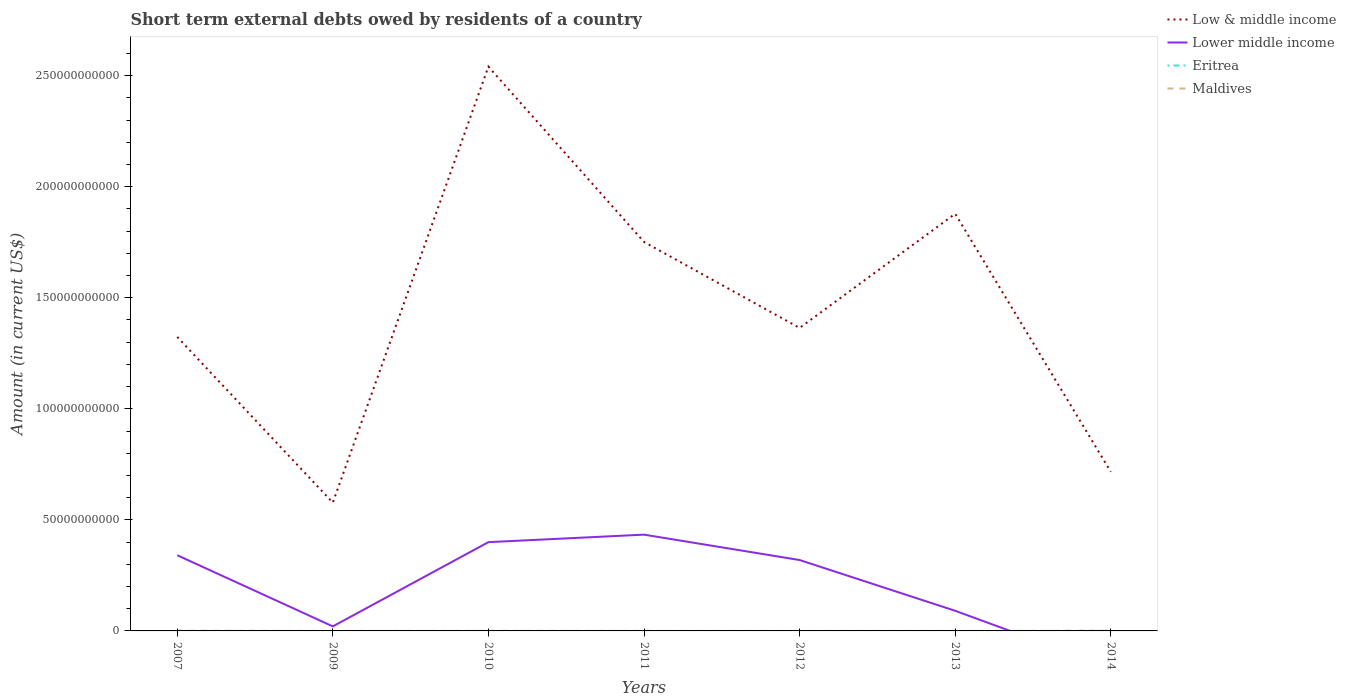How many different coloured lines are there?
Offer a terse response. 4. Is the number of lines equal to the number of legend labels?
Provide a short and direct response. No. Across all years, what is the maximum amount of short-term external debts owed by residents in Eritrea?
Offer a terse response. 0. What is the total amount of short-term external debts owed by residents in Low & middle income in the graph?
Your answer should be compact. -1.96e+11. What is the difference between the highest and the second highest amount of short-term external debts owed by residents in Low & middle income?
Ensure brevity in your answer.  1.96e+11. What is the difference between two consecutive major ticks on the Y-axis?
Offer a terse response. 5.00e+1. Are the values on the major ticks of Y-axis written in scientific E-notation?
Give a very brief answer. No. Does the graph contain any zero values?
Ensure brevity in your answer.  Yes. Does the graph contain grids?
Keep it short and to the point. No. Where does the legend appear in the graph?
Provide a succinct answer. Top right. How many legend labels are there?
Provide a short and direct response. 4. How are the legend labels stacked?
Make the answer very short. Vertical. What is the title of the graph?
Provide a succinct answer. Short term external debts owed by residents of a country. Does "Venezuela" appear as one of the legend labels in the graph?
Offer a terse response. No. What is the label or title of the Y-axis?
Offer a very short reply. Amount (in current US$). What is the Amount (in current US$) of Low & middle income in 2007?
Offer a terse response. 1.32e+11. What is the Amount (in current US$) in Lower middle income in 2007?
Keep it short and to the point. 3.41e+1. What is the Amount (in current US$) of Eritrea in 2007?
Ensure brevity in your answer.  0. What is the Amount (in current US$) in Maldives in 2007?
Ensure brevity in your answer.  8.91e+07. What is the Amount (in current US$) of Low & middle income in 2009?
Your answer should be very brief. 5.78e+1. What is the Amount (in current US$) in Lower middle income in 2009?
Offer a very short reply. 2.04e+09. What is the Amount (in current US$) in Eritrea in 2009?
Make the answer very short. 0. What is the Amount (in current US$) of Maldives in 2009?
Provide a short and direct response. 0. What is the Amount (in current US$) in Low & middle income in 2010?
Your answer should be very brief. 2.54e+11. What is the Amount (in current US$) in Lower middle income in 2010?
Provide a succinct answer. 4.00e+1. What is the Amount (in current US$) in Maldives in 2010?
Make the answer very short. 3.61e+07. What is the Amount (in current US$) of Low & middle income in 2011?
Provide a succinct answer. 1.75e+11. What is the Amount (in current US$) in Lower middle income in 2011?
Make the answer very short. 4.33e+1. What is the Amount (in current US$) of Maldives in 2011?
Ensure brevity in your answer.  7.15e+06. What is the Amount (in current US$) in Low & middle income in 2012?
Provide a short and direct response. 1.36e+11. What is the Amount (in current US$) in Lower middle income in 2012?
Offer a very short reply. 3.19e+1. What is the Amount (in current US$) in Maldives in 2012?
Your response must be concise. 0. What is the Amount (in current US$) in Low & middle income in 2013?
Give a very brief answer. 1.88e+11. What is the Amount (in current US$) in Lower middle income in 2013?
Keep it short and to the point. 9.06e+09. What is the Amount (in current US$) in Eritrea in 2013?
Offer a very short reply. 4.00e+06. What is the Amount (in current US$) in Low & middle income in 2014?
Offer a very short reply. 7.16e+1. What is the Amount (in current US$) in Lower middle income in 2014?
Ensure brevity in your answer.  0. What is the Amount (in current US$) in Eritrea in 2014?
Ensure brevity in your answer.  2.80e+07. What is the Amount (in current US$) of Maldives in 2014?
Your response must be concise. 9.82e+07. Across all years, what is the maximum Amount (in current US$) in Low & middle income?
Offer a terse response. 2.54e+11. Across all years, what is the maximum Amount (in current US$) of Lower middle income?
Your answer should be compact. 4.33e+1. Across all years, what is the maximum Amount (in current US$) of Eritrea?
Your response must be concise. 2.80e+07. Across all years, what is the maximum Amount (in current US$) of Maldives?
Keep it short and to the point. 9.82e+07. Across all years, what is the minimum Amount (in current US$) of Low & middle income?
Your response must be concise. 5.78e+1. Across all years, what is the minimum Amount (in current US$) of Lower middle income?
Offer a very short reply. 0. Across all years, what is the minimum Amount (in current US$) of Eritrea?
Ensure brevity in your answer.  0. Across all years, what is the minimum Amount (in current US$) in Maldives?
Provide a short and direct response. 0. What is the total Amount (in current US$) in Low & middle income in the graph?
Your response must be concise. 1.02e+12. What is the total Amount (in current US$) in Lower middle income in the graph?
Make the answer very short. 1.60e+11. What is the total Amount (in current US$) in Eritrea in the graph?
Make the answer very short. 3.50e+07. What is the total Amount (in current US$) in Maldives in the graph?
Give a very brief answer. 2.31e+08. What is the difference between the Amount (in current US$) of Low & middle income in 2007 and that in 2009?
Ensure brevity in your answer.  7.46e+1. What is the difference between the Amount (in current US$) in Lower middle income in 2007 and that in 2009?
Your answer should be compact. 3.20e+1. What is the difference between the Amount (in current US$) of Low & middle income in 2007 and that in 2010?
Ensure brevity in your answer.  -1.22e+11. What is the difference between the Amount (in current US$) in Lower middle income in 2007 and that in 2010?
Make the answer very short. -5.88e+09. What is the difference between the Amount (in current US$) in Maldives in 2007 and that in 2010?
Your answer should be compact. 5.30e+07. What is the difference between the Amount (in current US$) in Low & middle income in 2007 and that in 2011?
Keep it short and to the point. -4.28e+1. What is the difference between the Amount (in current US$) in Lower middle income in 2007 and that in 2011?
Ensure brevity in your answer.  -9.26e+09. What is the difference between the Amount (in current US$) in Maldives in 2007 and that in 2011?
Give a very brief answer. 8.19e+07. What is the difference between the Amount (in current US$) of Low & middle income in 2007 and that in 2012?
Provide a succinct answer. -4.05e+09. What is the difference between the Amount (in current US$) of Lower middle income in 2007 and that in 2012?
Offer a very short reply. 2.17e+09. What is the difference between the Amount (in current US$) of Low & middle income in 2007 and that in 2013?
Your answer should be very brief. -5.55e+1. What is the difference between the Amount (in current US$) in Lower middle income in 2007 and that in 2013?
Your response must be concise. 2.50e+1. What is the difference between the Amount (in current US$) of Low & middle income in 2007 and that in 2014?
Ensure brevity in your answer.  6.07e+1. What is the difference between the Amount (in current US$) in Maldives in 2007 and that in 2014?
Your answer should be very brief. -9.10e+06. What is the difference between the Amount (in current US$) of Low & middle income in 2009 and that in 2010?
Provide a short and direct response. -1.96e+11. What is the difference between the Amount (in current US$) of Lower middle income in 2009 and that in 2010?
Ensure brevity in your answer.  -3.79e+1. What is the difference between the Amount (in current US$) in Low & middle income in 2009 and that in 2011?
Offer a very short reply. -1.17e+11. What is the difference between the Amount (in current US$) in Lower middle income in 2009 and that in 2011?
Make the answer very short. -4.13e+1. What is the difference between the Amount (in current US$) of Low & middle income in 2009 and that in 2012?
Provide a succinct answer. -7.86e+1. What is the difference between the Amount (in current US$) of Lower middle income in 2009 and that in 2012?
Keep it short and to the point. -2.99e+1. What is the difference between the Amount (in current US$) of Low & middle income in 2009 and that in 2013?
Offer a terse response. -1.30e+11. What is the difference between the Amount (in current US$) of Lower middle income in 2009 and that in 2013?
Your answer should be very brief. -7.02e+09. What is the difference between the Amount (in current US$) in Low & middle income in 2009 and that in 2014?
Make the answer very short. -1.39e+1. What is the difference between the Amount (in current US$) in Low & middle income in 2010 and that in 2011?
Provide a succinct answer. 7.89e+1. What is the difference between the Amount (in current US$) of Lower middle income in 2010 and that in 2011?
Make the answer very short. -3.38e+09. What is the difference between the Amount (in current US$) in Eritrea in 2010 and that in 2011?
Your response must be concise. 1.00e+06. What is the difference between the Amount (in current US$) of Maldives in 2010 and that in 2011?
Provide a short and direct response. 2.90e+07. What is the difference between the Amount (in current US$) of Low & middle income in 2010 and that in 2012?
Your answer should be compact. 1.18e+11. What is the difference between the Amount (in current US$) of Lower middle income in 2010 and that in 2012?
Keep it short and to the point. 8.05e+09. What is the difference between the Amount (in current US$) in Low & middle income in 2010 and that in 2013?
Your answer should be very brief. 6.62e+1. What is the difference between the Amount (in current US$) of Lower middle income in 2010 and that in 2013?
Provide a short and direct response. 3.09e+1. What is the difference between the Amount (in current US$) of Low & middle income in 2010 and that in 2014?
Offer a very short reply. 1.82e+11. What is the difference between the Amount (in current US$) in Eritrea in 2010 and that in 2014?
Offer a very short reply. -2.60e+07. What is the difference between the Amount (in current US$) of Maldives in 2010 and that in 2014?
Ensure brevity in your answer.  -6.21e+07. What is the difference between the Amount (in current US$) of Low & middle income in 2011 and that in 2012?
Keep it short and to the point. 3.87e+1. What is the difference between the Amount (in current US$) of Lower middle income in 2011 and that in 2012?
Keep it short and to the point. 1.14e+1. What is the difference between the Amount (in current US$) of Low & middle income in 2011 and that in 2013?
Your answer should be compact. -1.27e+1. What is the difference between the Amount (in current US$) in Lower middle income in 2011 and that in 2013?
Offer a terse response. 3.43e+1. What is the difference between the Amount (in current US$) of Eritrea in 2011 and that in 2013?
Offer a very short reply. -3.00e+06. What is the difference between the Amount (in current US$) in Low & middle income in 2011 and that in 2014?
Your answer should be very brief. 1.03e+11. What is the difference between the Amount (in current US$) in Eritrea in 2011 and that in 2014?
Give a very brief answer. -2.70e+07. What is the difference between the Amount (in current US$) of Maldives in 2011 and that in 2014?
Provide a succinct answer. -9.10e+07. What is the difference between the Amount (in current US$) of Low & middle income in 2012 and that in 2013?
Your response must be concise. -5.14e+1. What is the difference between the Amount (in current US$) of Lower middle income in 2012 and that in 2013?
Make the answer very short. 2.29e+1. What is the difference between the Amount (in current US$) of Low & middle income in 2012 and that in 2014?
Make the answer very short. 6.48e+1. What is the difference between the Amount (in current US$) in Low & middle income in 2013 and that in 2014?
Offer a very short reply. 1.16e+11. What is the difference between the Amount (in current US$) in Eritrea in 2013 and that in 2014?
Your response must be concise. -2.40e+07. What is the difference between the Amount (in current US$) in Low & middle income in 2007 and the Amount (in current US$) in Lower middle income in 2009?
Your answer should be very brief. 1.30e+11. What is the difference between the Amount (in current US$) in Low & middle income in 2007 and the Amount (in current US$) in Lower middle income in 2010?
Offer a terse response. 9.24e+1. What is the difference between the Amount (in current US$) of Low & middle income in 2007 and the Amount (in current US$) of Eritrea in 2010?
Your answer should be very brief. 1.32e+11. What is the difference between the Amount (in current US$) in Low & middle income in 2007 and the Amount (in current US$) in Maldives in 2010?
Provide a succinct answer. 1.32e+11. What is the difference between the Amount (in current US$) in Lower middle income in 2007 and the Amount (in current US$) in Eritrea in 2010?
Offer a very short reply. 3.41e+1. What is the difference between the Amount (in current US$) in Lower middle income in 2007 and the Amount (in current US$) in Maldives in 2010?
Ensure brevity in your answer.  3.40e+1. What is the difference between the Amount (in current US$) of Low & middle income in 2007 and the Amount (in current US$) of Lower middle income in 2011?
Provide a short and direct response. 8.90e+1. What is the difference between the Amount (in current US$) of Low & middle income in 2007 and the Amount (in current US$) of Eritrea in 2011?
Give a very brief answer. 1.32e+11. What is the difference between the Amount (in current US$) in Low & middle income in 2007 and the Amount (in current US$) in Maldives in 2011?
Provide a succinct answer. 1.32e+11. What is the difference between the Amount (in current US$) in Lower middle income in 2007 and the Amount (in current US$) in Eritrea in 2011?
Provide a succinct answer. 3.41e+1. What is the difference between the Amount (in current US$) in Lower middle income in 2007 and the Amount (in current US$) in Maldives in 2011?
Ensure brevity in your answer.  3.41e+1. What is the difference between the Amount (in current US$) in Low & middle income in 2007 and the Amount (in current US$) in Lower middle income in 2012?
Offer a very short reply. 1.00e+11. What is the difference between the Amount (in current US$) of Low & middle income in 2007 and the Amount (in current US$) of Lower middle income in 2013?
Your answer should be compact. 1.23e+11. What is the difference between the Amount (in current US$) in Low & middle income in 2007 and the Amount (in current US$) in Eritrea in 2013?
Keep it short and to the point. 1.32e+11. What is the difference between the Amount (in current US$) in Lower middle income in 2007 and the Amount (in current US$) in Eritrea in 2013?
Give a very brief answer. 3.41e+1. What is the difference between the Amount (in current US$) in Low & middle income in 2007 and the Amount (in current US$) in Eritrea in 2014?
Offer a very short reply. 1.32e+11. What is the difference between the Amount (in current US$) of Low & middle income in 2007 and the Amount (in current US$) of Maldives in 2014?
Ensure brevity in your answer.  1.32e+11. What is the difference between the Amount (in current US$) in Lower middle income in 2007 and the Amount (in current US$) in Eritrea in 2014?
Offer a terse response. 3.41e+1. What is the difference between the Amount (in current US$) in Lower middle income in 2007 and the Amount (in current US$) in Maldives in 2014?
Keep it short and to the point. 3.40e+1. What is the difference between the Amount (in current US$) in Low & middle income in 2009 and the Amount (in current US$) in Lower middle income in 2010?
Provide a succinct answer. 1.78e+1. What is the difference between the Amount (in current US$) in Low & middle income in 2009 and the Amount (in current US$) in Eritrea in 2010?
Ensure brevity in your answer.  5.78e+1. What is the difference between the Amount (in current US$) of Low & middle income in 2009 and the Amount (in current US$) of Maldives in 2010?
Your answer should be very brief. 5.77e+1. What is the difference between the Amount (in current US$) of Lower middle income in 2009 and the Amount (in current US$) of Eritrea in 2010?
Give a very brief answer. 2.04e+09. What is the difference between the Amount (in current US$) in Lower middle income in 2009 and the Amount (in current US$) in Maldives in 2010?
Your answer should be very brief. 2.01e+09. What is the difference between the Amount (in current US$) in Low & middle income in 2009 and the Amount (in current US$) in Lower middle income in 2011?
Provide a short and direct response. 1.44e+1. What is the difference between the Amount (in current US$) of Low & middle income in 2009 and the Amount (in current US$) of Eritrea in 2011?
Your answer should be very brief. 5.78e+1. What is the difference between the Amount (in current US$) in Low & middle income in 2009 and the Amount (in current US$) in Maldives in 2011?
Your answer should be very brief. 5.78e+1. What is the difference between the Amount (in current US$) of Lower middle income in 2009 and the Amount (in current US$) of Eritrea in 2011?
Ensure brevity in your answer.  2.04e+09. What is the difference between the Amount (in current US$) in Lower middle income in 2009 and the Amount (in current US$) in Maldives in 2011?
Offer a terse response. 2.03e+09. What is the difference between the Amount (in current US$) of Low & middle income in 2009 and the Amount (in current US$) of Lower middle income in 2012?
Keep it short and to the point. 2.58e+1. What is the difference between the Amount (in current US$) in Low & middle income in 2009 and the Amount (in current US$) in Lower middle income in 2013?
Keep it short and to the point. 4.87e+1. What is the difference between the Amount (in current US$) in Low & middle income in 2009 and the Amount (in current US$) in Eritrea in 2013?
Offer a terse response. 5.78e+1. What is the difference between the Amount (in current US$) of Lower middle income in 2009 and the Amount (in current US$) of Eritrea in 2013?
Provide a short and direct response. 2.04e+09. What is the difference between the Amount (in current US$) of Low & middle income in 2009 and the Amount (in current US$) of Eritrea in 2014?
Offer a terse response. 5.77e+1. What is the difference between the Amount (in current US$) of Low & middle income in 2009 and the Amount (in current US$) of Maldives in 2014?
Provide a succinct answer. 5.77e+1. What is the difference between the Amount (in current US$) in Lower middle income in 2009 and the Amount (in current US$) in Eritrea in 2014?
Make the answer very short. 2.01e+09. What is the difference between the Amount (in current US$) in Lower middle income in 2009 and the Amount (in current US$) in Maldives in 2014?
Give a very brief answer. 1.94e+09. What is the difference between the Amount (in current US$) in Low & middle income in 2010 and the Amount (in current US$) in Lower middle income in 2011?
Give a very brief answer. 2.11e+11. What is the difference between the Amount (in current US$) of Low & middle income in 2010 and the Amount (in current US$) of Eritrea in 2011?
Your answer should be very brief. 2.54e+11. What is the difference between the Amount (in current US$) in Low & middle income in 2010 and the Amount (in current US$) in Maldives in 2011?
Your answer should be compact. 2.54e+11. What is the difference between the Amount (in current US$) of Lower middle income in 2010 and the Amount (in current US$) of Eritrea in 2011?
Your response must be concise. 4.00e+1. What is the difference between the Amount (in current US$) in Lower middle income in 2010 and the Amount (in current US$) in Maldives in 2011?
Your answer should be compact. 4.00e+1. What is the difference between the Amount (in current US$) in Eritrea in 2010 and the Amount (in current US$) in Maldives in 2011?
Offer a very short reply. -5.15e+06. What is the difference between the Amount (in current US$) in Low & middle income in 2010 and the Amount (in current US$) in Lower middle income in 2012?
Make the answer very short. 2.22e+11. What is the difference between the Amount (in current US$) in Low & middle income in 2010 and the Amount (in current US$) in Lower middle income in 2013?
Provide a succinct answer. 2.45e+11. What is the difference between the Amount (in current US$) in Low & middle income in 2010 and the Amount (in current US$) in Eritrea in 2013?
Provide a short and direct response. 2.54e+11. What is the difference between the Amount (in current US$) in Lower middle income in 2010 and the Amount (in current US$) in Eritrea in 2013?
Your answer should be very brief. 4.00e+1. What is the difference between the Amount (in current US$) in Low & middle income in 2010 and the Amount (in current US$) in Eritrea in 2014?
Provide a short and direct response. 2.54e+11. What is the difference between the Amount (in current US$) in Low & middle income in 2010 and the Amount (in current US$) in Maldives in 2014?
Provide a short and direct response. 2.54e+11. What is the difference between the Amount (in current US$) in Lower middle income in 2010 and the Amount (in current US$) in Eritrea in 2014?
Make the answer very short. 3.99e+1. What is the difference between the Amount (in current US$) in Lower middle income in 2010 and the Amount (in current US$) in Maldives in 2014?
Your answer should be compact. 3.99e+1. What is the difference between the Amount (in current US$) in Eritrea in 2010 and the Amount (in current US$) in Maldives in 2014?
Your answer should be compact. -9.62e+07. What is the difference between the Amount (in current US$) of Low & middle income in 2011 and the Amount (in current US$) of Lower middle income in 2012?
Ensure brevity in your answer.  1.43e+11. What is the difference between the Amount (in current US$) of Low & middle income in 2011 and the Amount (in current US$) of Lower middle income in 2013?
Offer a very short reply. 1.66e+11. What is the difference between the Amount (in current US$) of Low & middle income in 2011 and the Amount (in current US$) of Eritrea in 2013?
Offer a terse response. 1.75e+11. What is the difference between the Amount (in current US$) of Lower middle income in 2011 and the Amount (in current US$) of Eritrea in 2013?
Offer a terse response. 4.33e+1. What is the difference between the Amount (in current US$) of Low & middle income in 2011 and the Amount (in current US$) of Eritrea in 2014?
Your answer should be very brief. 1.75e+11. What is the difference between the Amount (in current US$) in Low & middle income in 2011 and the Amount (in current US$) in Maldives in 2014?
Provide a succinct answer. 1.75e+11. What is the difference between the Amount (in current US$) in Lower middle income in 2011 and the Amount (in current US$) in Eritrea in 2014?
Offer a very short reply. 4.33e+1. What is the difference between the Amount (in current US$) of Lower middle income in 2011 and the Amount (in current US$) of Maldives in 2014?
Offer a terse response. 4.32e+1. What is the difference between the Amount (in current US$) in Eritrea in 2011 and the Amount (in current US$) in Maldives in 2014?
Your answer should be compact. -9.72e+07. What is the difference between the Amount (in current US$) in Low & middle income in 2012 and the Amount (in current US$) in Lower middle income in 2013?
Provide a short and direct response. 1.27e+11. What is the difference between the Amount (in current US$) of Low & middle income in 2012 and the Amount (in current US$) of Eritrea in 2013?
Ensure brevity in your answer.  1.36e+11. What is the difference between the Amount (in current US$) in Lower middle income in 2012 and the Amount (in current US$) in Eritrea in 2013?
Offer a very short reply. 3.19e+1. What is the difference between the Amount (in current US$) in Low & middle income in 2012 and the Amount (in current US$) in Eritrea in 2014?
Provide a succinct answer. 1.36e+11. What is the difference between the Amount (in current US$) in Low & middle income in 2012 and the Amount (in current US$) in Maldives in 2014?
Offer a terse response. 1.36e+11. What is the difference between the Amount (in current US$) in Lower middle income in 2012 and the Amount (in current US$) in Eritrea in 2014?
Provide a short and direct response. 3.19e+1. What is the difference between the Amount (in current US$) in Lower middle income in 2012 and the Amount (in current US$) in Maldives in 2014?
Give a very brief answer. 3.18e+1. What is the difference between the Amount (in current US$) of Low & middle income in 2013 and the Amount (in current US$) of Eritrea in 2014?
Your answer should be very brief. 1.88e+11. What is the difference between the Amount (in current US$) of Low & middle income in 2013 and the Amount (in current US$) of Maldives in 2014?
Give a very brief answer. 1.88e+11. What is the difference between the Amount (in current US$) of Lower middle income in 2013 and the Amount (in current US$) of Eritrea in 2014?
Keep it short and to the point. 9.03e+09. What is the difference between the Amount (in current US$) in Lower middle income in 2013 and the Amount (in current US$) in Maldives in 2014?
Keep it short and to the point. 8.96e+09. What is the difference between the Amount (in current US$) in Eritrea in 2013 and the Amount (in current US$) in Maldives in 2014?
Provide a succinct answer. -9.42e+07. What is the average Amount (in current US$) in Low & middle income per year?
Your answer should be compact. 1.45e+11. What is the average Amount (in current US$) in Lower middle income per year?
Your answer should be very brief. 2.29e+1. What is the average Amount (in current US$) in Eritrea per year?
Your answer should be very brief. 5.00e+06. What is the average Amount (in current US$) of Maldives per year?
Offer a terse response. 3.29e+07. In the year 2007, what is the difference between the Amount (in current US$) in Low & middle income and Amount (in current US$) in Lower middle income?
Ensure brevity in your answer.  9.83e+1. In the year 2007, what is the difference between the Amount (in current US$) in Low & middle income and Amount (in current US$) in Maldives?
Your answer should be very brief. 1.32e+11. In the year 2007, what is the difference between the Amount (in current US$) in Lower middle income and Amount (in current US$) in Maldives?
Your answer should be very brief. 3.40e+1. In the year 2009, what is the difference between the Amount (in current US$) in Low & middle income and Amount (in current US$) in Lower middle income?
Give a very brief answer. 5.57e+1. In the year 2010, what is the difference between the Amount (in current US$) in Low & middle income and Amount (in current US$) in Lower middle income?
Your answer should be very brief. 2.14e+11. In the year 2010, what is the difference between the Amount (in current US$) in Low & middle income and Amount (in current US$) in Eritrea?
Your answer should be very brief. 2.54e+11. In the year 2010, what is the difference between the Amount (in current US$) in Low & middle income and Amount (in current US$) in Maldives?
Offer a terse response. 2.54e+11. In the year 2010, what is the difference between the Amount (in current US$) of Lower middle income and Amount (in current US$) of Eritrea?
Offer a terse response. 4.00e+1. In the year 2010, what is the difference between the Amount (in current US$) of Lower middle income and Amount (in current US$) of Maldives?
Your response must be concise. 3.99e+1. In the year 2010, what is the difference between the Amount (in current US$) of Eritrea and Amount (in current US$) of Maldives?
Provide a short and direct response. -3.41e+07. In the year 2011, what is the difference between the Amount (in current US$) in Low & middle income and Amount (in current US$) in Lower middle income?
Your answer should be compact. 1.32e+11. In the year 2011, what is the difference between the Amount (in current US$) of Low & middle income and Amount (in current US$) of Eritrea?
Provide a succinct answer. 1.75e+11. In the year 2011, what is the difference between the Amount (in current US$) in Low & middle income and Amount (in current US$) in Maldives?
Give a very brief answer. 1.75e+11. In the year 2011, what is the difference between the Amount (in current US$) in Lower middle income and Amount (in current US$) in Eritrea?
Give a very brief answer. 4.33e+1. In the year 2011, what is the difference between the Amount (in current US$) in Lower middle income and Amount (in current US$) in Maldives?
Keep it short and to the point. 4.33e+1. In the year 2011, what is the difference between the Amount (in current US$) in Eritrea and Amount (in current US$) in Maldives?
Your answer should be very brief. -6.15e+06. In the year 2012, what is the difference between the Amount (in current US$) of Low & middle income and Amount (in current US$) of Lower middle income?
Your answer should be compact. 1.04e+11. In the year 2013, what is the difference between the Amount (in current US$) of Low & middle income and Amount (in current US$) of Lower middle income?
Give a very brief answer. 1.79e+11. In the year 2013, what is the difference between the Amount (in current US$) of Low & middle income and Amount (in current US$) of Eritrea?
Offer a terse response. 1.88e+11. In the year 2013, what is the difference between the Amount (in current US$) in Lower middle income and Amount (in current US$) in Eritrea?
Offer a terse response. 9.05e+09. In the year 2014, what is the difference between the Amount (in current US$) in Low & middle income and Amount (in current US$) in Eritrea?
Your answer should be very brief. 7.16e+1. In the year 2014, what is the difference between the Amount (in current US$) of Low & middle income and Amount (in current US$) of Maldives?
Your response must be concise. 7.15e+1. In the year 2014, what is the difference between the Amount (in current US$) in Eritrea and Amount (in current US$) in Maldives?
Keep it short and to the point. -7.02e+07. What is the ratio of the Amount (in current US$) of Low & middle income in 2007 to that in 2009?
Make the answer very short. 2.29. What is the ratio of the Amount (in current US$) of Lower middle income in 2007 to that in 2009?
Offer a very short reply. 16.7. What is the ratio of the Amount (in current US$) in Low & middle income in 2007 to that in 2010?
Offer a very short reply. 0.52. What is the ratio of the Amount (in current US$) of Lower middle income in 2007 to that in 2010?
Keep it short and to the point. 0.85. What is the ratio of the Amount (in current US$) in Maldives in 2007 to that in 2010?
Make the answer very short. 2.47. What is the ratio of the Amount (in current US$) of Low & middle income in 2007 to that in 2011?
Make the answer very short. 0.76. What is the ratio of the Amount (in current US$) of Lower middle income in 2007 to that in 2011?
Give a very brief answer. 0.79. What is the ratio of the Amount (in current US$) of Maldives in 2007 to that in 2011?
Provide a short and direct response. 12.46. What is the ratio of the Amount (in current US$) in Low & middle income in 2007 to that in 2012?
Provide a short and direct response. 0.97. What is the ratio of the Amount (in current US$) in Lower middle income in 2007 to that in 2012?
Offer a very short reply. 1.07. What is the ratio of the Amount (in current US$) in Low & middle income in 2007 to that in 2013?
Offer a terse response. 0.7. What is the ratio of the Amount (in current US$) of Lower middle income in 2007 to that in 2013?
Give a very brief answer. 3.76. What is the ratio of the Amount (in current US$) of Low & middle income in 2007 to that in 2014?
Give a very brief answer. 1.85. What is the ratio of the Amount (in current US$) of Maldives in 2007 to that in 2014?
Provide a succinct answer. 0.91. What is the ratio of the Amount (in current US$) of Low & middle income in 2009 to that in 2010?
Make the answer very short. 0.23. What is the ratio of the Amount (in current US$) in Lower middle income in 2009 to that in 2010?
Offer a terse response. 0.05. What is the ratio of the Amount (in current US$) of Low & middle income in 2009 to that in 2011?
Offer a very short reply. 0.33. What is the ratio of the Amount (in current US$) of Lower middle income in 2009 to that in 2011?
Your response must be concise. 0.05. What is the ratio of the Amount (in current US$) of Low & middle income in 2009 to that in 2012?
Offer a very short reply. 0.42. What is the ratio of the Amount (in current US$) of Lower middle income in 2009 to that in 2012?
Provide a short and direct response. 0.06. What is the ratio of the Amount (in current US$) in Low & middle income in 2009 to that in 2013?
Keep it short and to the point. 0.31. What is the ratio of the Amount (in current US$) of Lower middle income in 2009 to that in 2013?
Offer a terse response. 0.23. What is the ratio of the Amount (in current US$) of Low & middle income in 2009 to that in 2014?
Ensure brevity in your answer.  0.81. What is the ratio of the Amount (in current US$) in Low & middle income in 2010 to that in 2011?
Provide a short and direct response. 1.45. What is the ratio of the Amount (in current US$) in Lower middle income in 2010 to that in 2011?
Give a very brief answer. 0.92. What is the ratio of the Amount (in current US$) of Eritrea in 2010 to that in 2011?
Provide a short and direct response. 2. What is the ratio of the Amount (in current US$) in Maldives in 2010 to that in 2011?
Make the answer very short. 5.05. What is the ratio of the Amount (in current US$) of Low & middle income in 2010 to that in 2012?
Offer a very short reply. 1.86. What is the ratio of the Amount (in current US$) of Lower middle income in 2010 to that in 2012?
Offer a very short reply. 1.25. What is the ratio of the Amount (in current US$) of Low & middle income in 2010 to that in 2013?
Your response must be concise. 1.35. What is the ratio of the Amount (in current US$) in Lower middle income in 2010 to that in 2013?
Give a very brief answer. 4.41. What is the ratio of the Amount (in current US$) in Low & middle income in 2010 to that in 2014?
Offer a very short reply. 3.55. What is the ratio of the Amount (in current US$) of Eritrea in 2010 to that in 2014?
Offer a terse response. 0.07. What is the ratio of the Amount (in current US$) in Maldives in 2010 to that in 2014?
Offer a terse response. 0.37. What is the ratio of the Amount (in current US$) of Low & middle income in 2011 to that in 2012?
Make the answer very short. 1.28. What is the ratio of the Amount (in current US$) in Lower middle income in 2011 to that in 2012?
Provide a succinct answer. 1.36. What is the ratio of the Amount (in current US$) of Low & middle income in 2011 to that in 2013?
Keep it short and to the point. 0.93. What is the ratio of the Amount (in current US$) in Lower middle income in 2011 to that in 2013?
Your answer should be very brief. 4.79. What is the ratio of the Amount (in current US$) in Low & middle income in 2011 to that in 2014?
Ensure brevity in your answer.  2.44. What is the ratio of the Amount (in current US$) in Eritrea in 2011 to that in 2014?
Ensure brevity in your answer.  0.04. What is the ratio of the Amount (in current US$) of Maldives in 2011 to that in 2014?
Your answer should be very brief. 0.07. What is the ratio of the Amount (in current US$) of Low & middle income in 2012 to that in 2013?
Offer a very short reply. 0.73. What is the ratio of the Amount (in current US$) of Lower middle income in 2012 to that in 2013?
Offer a very short reply. 3.52. What is the ratio of the Amount (in current US$) of Low & middle income in 2012 to that in 2014?
Your response must be concise. 1.9. What is the ratio of the Amount (in current US$) in Low & middle income in 2013 to that in 2014?
Offer a terse response. 2.62. What is the ratio of the Amount (in current US$) in Eritrea in 2013 to that in 2014?
Your response must be concise. 0.14. What is the difference between the highest and the second highest Amount (in current US$) of Low & middle income?
Offer a terse response. 6.62e+1. What is the difference between the highest and the second highest Amount (in current US$) in Lower middle income?
Ensure brevity in your answer.  3.38e+09. What is the difference between the highest and the second highest Amount (in current US$) of Eritrea?
Offer a terse response. 2.40e+07. What is the difference between the highest and the second highest Amount (in current US$) in Maldives?
Provide a short and direct response. 9.10e+06. What is the difference between the highest and the lowest Amount (in current US$) of Low & middle income?
Give a very brief answer. 1.96e+11. What is the difference between the highest and the lowest Amount (in current US$) in Lower middle income?
Offer a very short reply. 4.33e+1. What is the difference between the highest and the lowest Amount (in current US$) in Eritrea?
Your answer should be very brief. 2.80e+07. What is the difference between the highest and the lowest Amount (in current US$) in Maldives?
Give a very brief answer. 9.82e+07. 